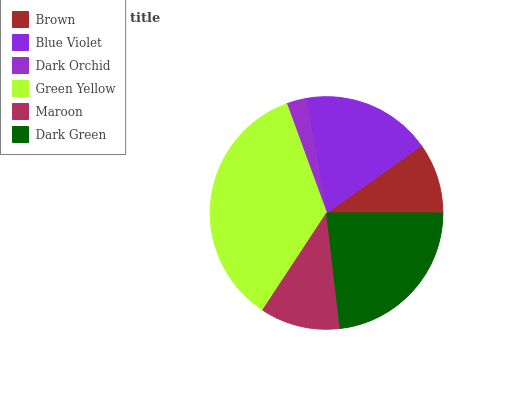Is Dark Orchid the minimum?
Answer yes or no. Yes. Is Green Yellow the maximum?
Answer yes or no. Yes. Is Blue Violet the minimum?
Answer yes or no. No. Is Blue Violet the maximum?
Answer yes or no. No. Is Blue Violet greater than Brown?
Answer yes or no. Yes. Is Brown less than Blue Violet?
Answer yes or no. Yes. Is Brown greater than Blue Violet?
Answer yes or no. No. Is Blue Violet less than Brown?
Answer yes or no. No. Is Blue Violet the high median?
Answer yes or no. Yes. Is Maroon the low median?
Answer yes or no. Yes. Is Green Yellow the high median?
Answer yes or no. No. Is Brown the low median?
Answer yes or no. No. 